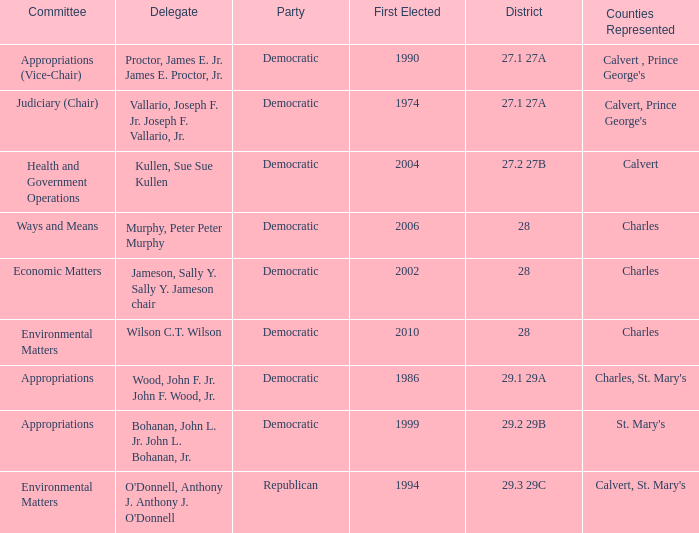When first elected was 2006, who was the delegate? Murphy, Peter Peter Murphy. 